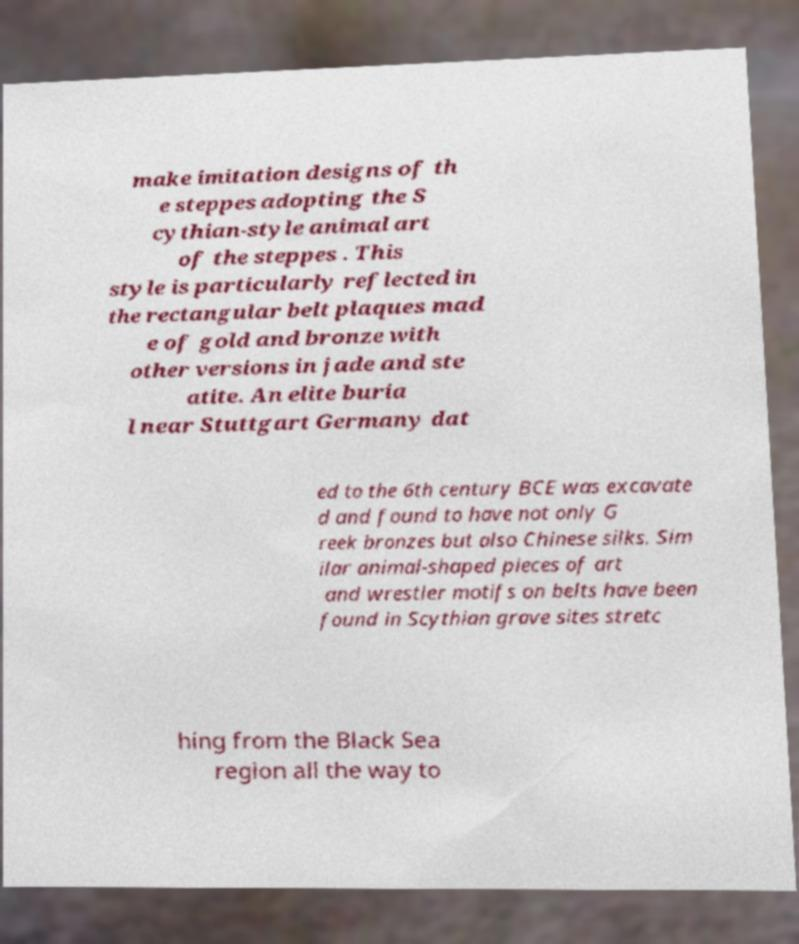Can you read and provide the text displayed in the image?This photo seems to have some interesting text. Can you extract and type it out for me? make imitation designs of th e steppes adopting the S cythian-style animal art of the steppes . This style is particularly reflected in the rectangular belt plaques mad e of gold and bronze with other versions in jade and ste atite. An elite buria l near Stuttgart Germany dat ed to the 6th century BCE was excavate d and found to have not only G reek bronzes but also Chinese silks. Sim ilar animal-shaped pieces of art and wrestler motifs on belts have been found in Scythian grave sites stretc hing from the Black Sea region all the way to 